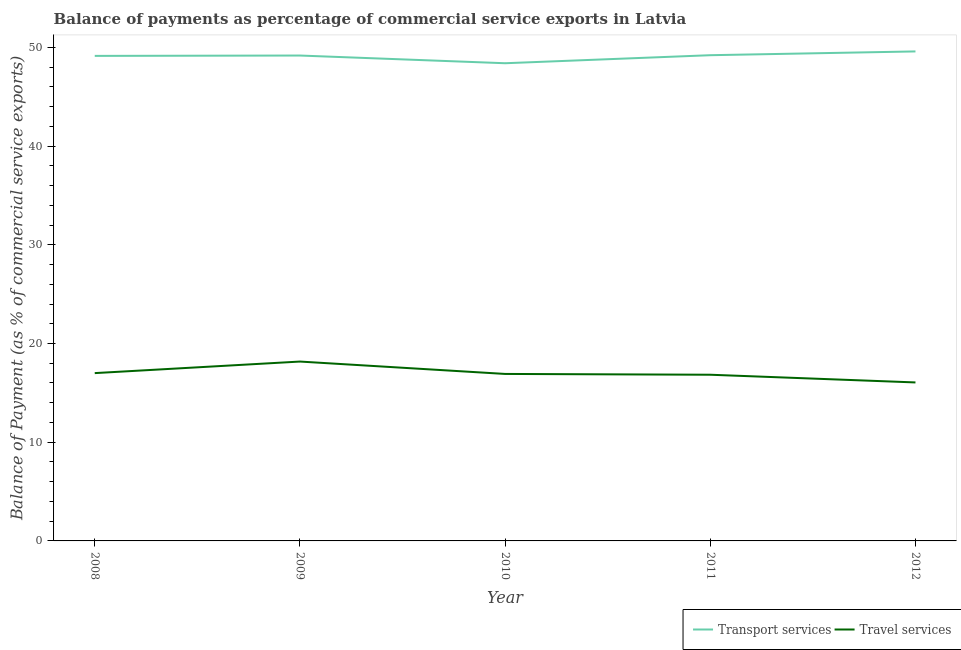How many different coloured lines are there?
Your answer should be compact. 2. Is the number of lines equal to the number of legend labels?
Provide a short and direct response. Yes. What is the balance of payments of travel services in 2012?
Give a very brief answer. 16.06. Across all years, what is the maximum balance of payments of transport services?
Keep it short and to the point. 49.59. Across all years, what is the minimum balance of payments of transport services?
Provide a short and direct response. 48.39. What is the total balance of payments of travel services in the graph?
Make the answer very short. 84.98. What is the difference between the balance of payments of travel services in 2009 and that in 2011?
Give a very brief answer. 1.34. What is the difference between the balance of payments of travel services in 2011 and the balance of payments of transport services in 2009?
Offer a very short reply. -32.34. What is the average balance of payments of travel services per year?
Your answer should be very brief. 17. In the year 2008, what is the difference between the balance of payments of travel services and balance of payments of transport services?
Make the answer very short. -32.13. In how many years, is the balance of payments of transport services greater than 26 %?
Provide a short and direct response. 5. What is the ratio of the balance of payments of travel services in 2008 to that in 2012?
Provide a short and direct response. 1.06. What is the difference between the highest and the second highest balance of payments of travel services?
Offer a very short reply. 1.17. What is the difference between the highest and the lowest balance of payments of transport services?
Offer a terse response. 1.2. Is the sum of the balance of payments of travel services in 2008 and 2009 greater than the maximum balance of payments of transport services across all years?
Offer a very short reply. No. Is the balance of payments of travel services strictly greater than the balance of payments of transport services over the years?
Your answer should be compact. No. Is the balance of payments of travel services strictly less than the balance of payments of transport services over the years?
Give a very brief answer. Yes. How many lines are there?
Give a very brief answer. 2. Does the graph contain grids?
Provide a succinct answer. No. Where does the legend appear in the graph?
Offer a very short reply. Bottom right. How many legend labels are there?
Provide a short and direct response. 2. How are the legend labels stacked?
Your answer should be very brief. Horizontal. What is the title of the graph?
Your answer should be very brief. Balance of payments as percentage of commercial service exports in Latvia. Does "Primary income" appear as one of the legend labels in the graph?
Give a very brief answer. No. What is the label or title of the X-axis?
Keep it short and to the point. Year. What is the label or title of the Y-axis?
Your answer should be very brief. Balance of Payment (as % of commercial service exports). What is the Balance of Payment (as % of commercial service exports) in Transport services in 2008?
Offer a terse response. 49.13. What is the Balance of Payment (as % of commercial service exports) of Travel services in 2008?
Make the answer very short. 17. What is the Balance of Payment (as % of commercial service exports) in Transport services in 2009?
Ensure brevity in your answer.  49.17. What is the Balance of Payment (as % of commercial service exports) in Travel services in 2009?
Your answer should be very brief. 18.17. What is the Balance of Payment (as % of commercial service exports) in Transport services in 2010?
Make the answer very short. 48.39. What is the Balance of Payment (as % of commercial service exports) in Travel services in 2010?
Keep it short and to the point. 16.92. What is the Balance of Payment (as % of commercial service exports) of Transport services in 2011?
Ensure brevity in your answer.  49.2. What is the Balance of Payment (as % of commercial service exports) in Travel services in 2011?
Your answer should be very brief. 16.84. What is the Balance of Payment (as % of commercial service exports) of Transport services in 2012?
Ensure brevity in your answer.  49.59. What is the Balance of Payment (as % of commercial service exports) of Travel services in 2012?
Provide a succinct answer. 16.06. Across all years, what is the maximum Balance of Payment (as % of commercial service exports) in Transport services?
Keep it short and to the point. 49.59. Across all years, what is the maximum Balance of Payment (as % of commercial service exports) of Travel services?
Provide a short and direct response. 18.17. Across all years, what is the minimum Balance of Payment (as % of commercial service exports) in Transport services?
Give a very brief answer. 48.39. Across all years, what is the minimum Balance of Payment (as % of commercial service exports) in Travel services?
Give a very brief answer. 16.06. What is the total Balance of Payment (as % of commercial service exports) in Transport services in the graph?
Provide a succinct answer. 245.49. What is the total Balance of Payment (as % of commercial service exports) in Travel services in the graph?
Keep it short and to the point. 84.98. What is the difference between the Balance of Payment (as % of commercial service exports) of Transport services in 2008 and that in 2009?
Provide a succinct answer. -0.04. What is the difference between the Balance of Payment (as % of commercial service exports) in Travel services in 2008 and that in 2009?
Your answer should be compact. -1.17. What is the difference between the Balance of Payment (as % of commercial service exports) of Transport services in 2008 and that in 2010?
Provide a short and direct response. 0.74. What is the difference between the Balance of Payment (as % of commercial service exports) in Travel services in 2008 and that in 2010?
Provide a succinct answer. 0.08. What is the difference between the Balance of Payment (as % of commercial service exports) of Transport services in 2008 and that in 2011?
Offer a very short reply. -0.07. What is the difference between the Balance of Payment (as % of commercial service exports) in Travel services in 2008 and that in 2011?
Your answer should be compact. 0.16. What is the difference between the Balance of Payment (as % of commercial service exports) in Transport services in 2008 and that in 2012?
Keep it short and to the point. -0.45. What is the difference between the Balance of Payment (as % of commercial service exports) in Travel services in 2008 and that in 2012?
Provide a succinct answer. 0.94. What is the difference between the Balance of Payment (as % of commercial service exports) in Transport services in 2009 and that in 2010?
Give a very brief answer. 0.78. What is the difference between the Balance of Payment (as % of commercial service exports) of Travel services in 2009 and that in 2010?
Offer a terse response. 1.25. What is the difference between the Balance of Payment (as % of commercial service exports) of Transport services in 2009 and that in 2011?
Your answer should be very brief. -0.03. What is the difference between the Balance of Payment (as % of commercial service exports) of Travel services in 2009 and that in 2011?
Provide a succinct answer. 1.34. What is the difference between the Balance of Payment (as % of commercial service exports) in Transport services in 2009 and that in 2012?
Keep it short and to the point. -0.42. What is the difference between the Balance of Payment (as % of commercial service exports) of Travel services in 2009 and that in 2012?
Provide a short and direct response. 2.11. What is the difference between the Balance of Payment (as % of commercial service exports) in Transport services in 2010 and that in 2011?
Provide a short and direct response. -0.81. What is the difference between the Balance of Payment (as % of commercial service exports) in Travel services in 2010 and that in 2011?
Your response must be concise. 0.08. What is the difference between the Balance of Payment (as % of commercial service exports) in Transport services in 2010 and that in 2012?
Your answer should be very brief. -1.2. What is the difference between the Balance of Payment (as % of commercial service exports) of Travel services in 2010 and that in 2012?
Provide a succinct answer. 0.86. What is the difference between the Balance of Payment (as % of commercial service exports) in Transport services in 2011 and that in 2012?
Provide a short and direct response. -0.38. What is the difference between the Balance of Payment (as % of commercial service exports) in Travel services in 2011 and that in 2012?
Give a very brief answer. 0.78. What is the difference between the Balance of Payment (as % of commercial service exports) in Transport services in 2008 and the Balance of Payment (as % of commercial service exports) in Travel services in 2009?
Your answer should be very brief. 30.96. What is the difference between the Balance of Payment (as % of commercial service exports) of Transport services in 2008 and the Balance of Payment (as % of commercial service exports) of Travel services in 2010?
Your answer should be very brief. 32.22. What is the difference between the Balance of Payment (as % of commercial service exports) in Transport services in 2008 and the Balance of Payment (as % of commercial service exports) in Travel services in 2011?
Your response must be concise. 32.3. What is the difference between the Balance of Payment (as % of commercial service exports) of Transport services in 2008 and the Balance of Payment (as % of commercial service exports) of Travel services in 2012?
Your response must be concise. 33.08. What is the difference between the Balance of Payment (as % of commercial service exports) of Transport services in 2009 and the Balance of Payment (as % of commercial service exports) of Travel services in 2010?
Give a very brief answer. 32.26. What is the difference between the Balance of Payment (as % of commercial service exports) in Transport services in 2009 and the Balance of Payment (as % of commercial service exports) in Travel services in 2011?
Your answer should be very brief. 32.34. What is the difference between the Balance of Payment (as % of commercial service exports) in Transport services in 2009 and the Balance of Payment (as % of commercial service exports) in Travel services in 2012?
Provide a short and direct response. 33.12. What is the difference between the Balance of Payment (as % of commercial service exports) in Transport services in 2010 and the Balance of Payment (as % of commercial service exports) in Travel services in 2011?
Make the answer very short. 31.56. What is the difference between the Balance of Payment (as % of commercial service exports) of Transport services in 2010 and the Balance of Payment (as % of commercial service exports) of Travel services in 2012?
Offer a terse response. 32.33. What is the difference between the Balance of Payment (as % of commercial service exports) in Transport services in 2011 and the Balance of Payment (as % of commercial service exports) in Travel services in 2012?
Offer a very short reply. 33.15. What is the average Balance of Payment (as % of commercial service exports) of Transport services per year?
Offer a very short reply. 49.1. What is the average Balance of Payment (as % of commercial service exports) in Travel services per year?
Keep it short and to the point. 17. In the year 2008, what is the difference between the Balance of Payment (as % of commercial service exports) in Transport services and Balance of Payment (as % of commercial service exports) in Travel services?
Your response must be concise. 32.13. In the year 2009, what is the difference between the Balance of Payment (as % of commercial service exports) of Transport services and Balance of Payment (as % of commercial service exports) of Travel services?
Your response must be concise. 31. In the year 2010, what is the difference between the Balance of Payment (as % of commercial service exports) in Transport services and Balance of Payment (as % of commercial service exports) in Travel services?
Offer a very short reply. 31.47. In the year 2011, what is the difference between the Balance of Payment (as % of commercial service exports) of Transport services and Balance of Payment (as % of commercial service exports) of Travel services?
Make the answer very short. 32.37. In the year 2012, what is the difference between the Balance of Payment (as % of commercial service exports) in Transport services and Balance of Payment (as % of commercial service exports) in Travel services?
Your response must be concise. 33.53. What is the ratio of the Balance of Payment (as % of commercial service exports) of Transport services in 2008 to that in 2009?
Make the answer very short. 1. What is the ratio of the Balance of Payment (as % of commercial service exports) in Travel services in 2008 to that in 2009?
Your answer should be very brief. 0.94. What is the ratio of the Balance of Payment (as % of commercial service exports) in Transport services in 2008 to that in 2010?
Provide a succinct answer. 1.02. What is the ratio of the Balance of Payment (as % of commercial service exports) of Travel services in 2008 to that in 2010?
Make the answer very short. 1. What is the ratio of the Balance of Payment (as % of commercial service exports) of Travel services in 2008 to that in 2011?
Your response must be concise. 1.01. What is the ratio of the Balance of Payment (as % of commercial service exports) of Transport services in 2008 to that in 2012?
Your answer should be compact. 0.99. What is the ratio of the Balance of Payment (as % of commercial service exports) in Travel services in 2008 to that in 2012?
Ensure brevity in your answer.  1.06. What is the ratio of the Balance of Payment (as % of commercial service exports) in Transport services in 2009 to that in 2010?
Your response must be concise. 1.02. What is the ratio of the Balance of Payment (as % of commercial service exports) of Travel services in 2009 to that in 2010?
Offer a very short reply. 1.07. What is the ratio of the Balance of Payment (as % of commercial service exports) in Transport services in 2009 to that in 2011?
Your answer should be compact. 1. What is the ratio of the Balance of Payment (as % of commercial service exports) in Travel services in 2009 to that in 2011?
Your response must be concise. 1.08. What is the ratio of the Balance of Payment (as % of commercial service exports) in Transport services in 2009 to that in 2012?
Offer a terse response. 0.99. What is the ratio of the Balance of Payment (as % of commercial service exports) of Travel services in 2009 to that in 2012?
Provide a short and direct response. 1.13. What is the ratio of the Balance of Payment (as % of commercial service exports) in Transport services in 2010 to that in 2011?
Provide a short and direct response. 0.98. What is the ratio of the Balance of Payment (as % of commercial service exports) of Transport services in 2010 to that in 2012?
Keep it short and to the point. 0.98. What is the ratio of the Balance of Payment (as % of commercial service exports) in Travel services in 2010 to that in 2012?
Provide a short and direct response. 1.05. What is the ratio of the Balance of Payment (as % of commercial service exports) in Transport services in 2011 to that in 2012?
Make the answer very short. 0.99. What is the ratio of the Balance of Payment (as % of commercial service exports) in Travel services in 2011 to that in 2012?
Your answer should be very brief. 1.05. What is the difference between the highest and the second highest Balance of Payment (as % of commercial service exports) of Transport services?
Provide a succinct answer. 0.38. What is the difference between the highest and the second highest Balance of Payment (as % of commercial service exports) of Travel services?
Your response must be concise. 1.17. What is the difference between the highest and the lowest Balance of Payment (as % of commercial service exports) in Transport services?
Provide a short and direct response. 1.2. What is the difference between the highest and the lowest Balance of Payment (as % of commercial service exports) in Travel services?
Your response must be concise. 2.11. 